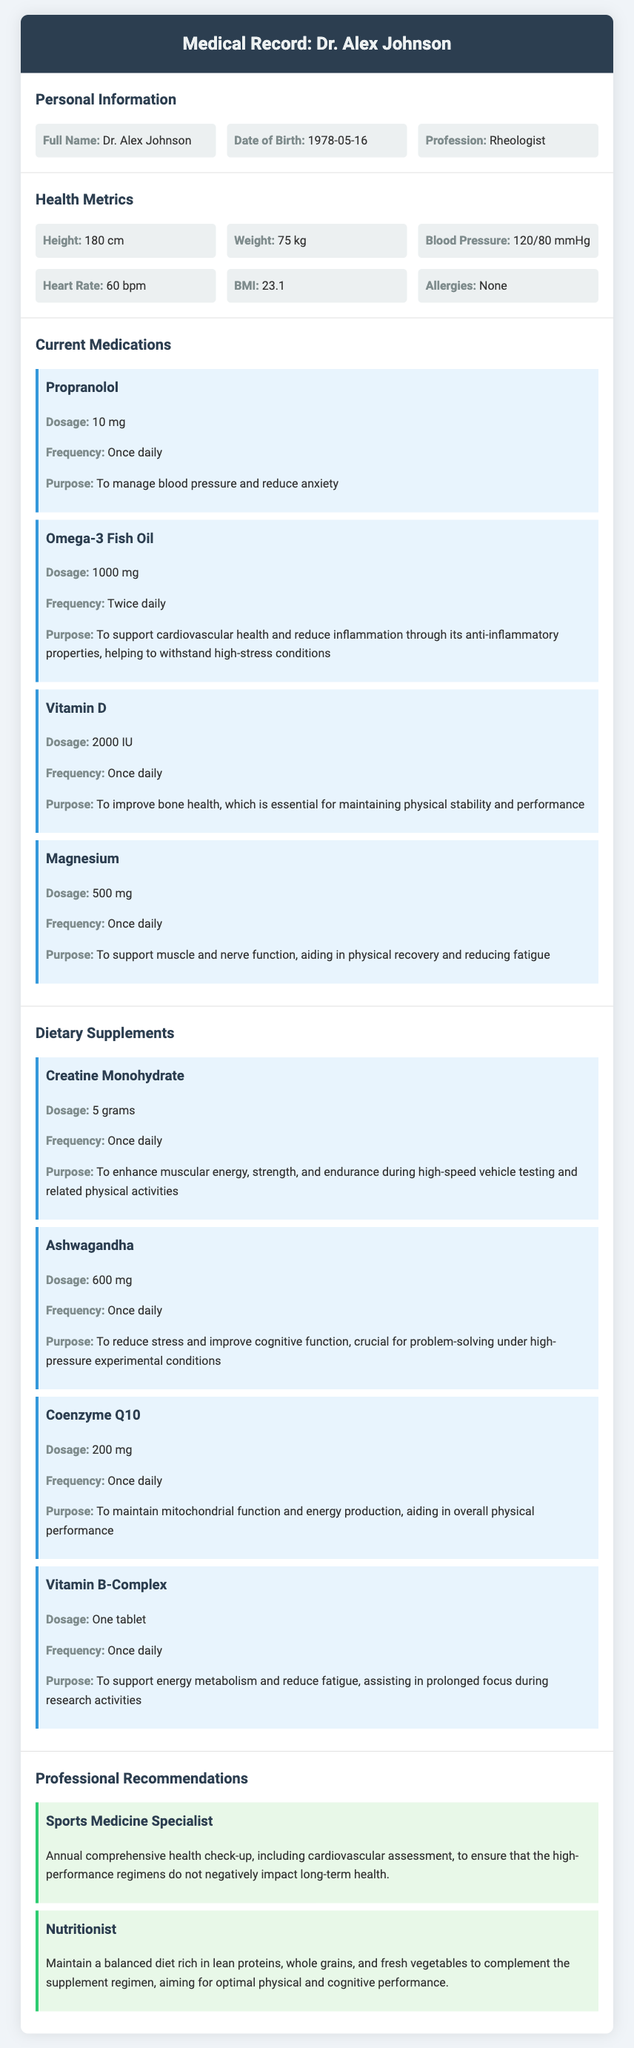what is the full name of the patient? The full name of the patient is stated in the personal information section.
Answer: Dr. Alex Johnson what is the dosage of Omega-3 Fish Oil? The dosage for Omega-3 Fish Oil is provided in the current medications section.
Answer: 1000 mg how often should Vitamin D be taken? The frequency of Vitamin D intake is indicated in the current medications section.
Answer: Once daily what is the purpose of taking Ashwagandha? The purpose of Ashwagandha is described in the dietary supplements section.
Answer: To reduce stress and improve cognitive function who is recommended for an annual comprehensive health check-up? The recommendation for health check-up is mentioned in the professional recommendations section.
Answer: Sports Medicine Specialist 